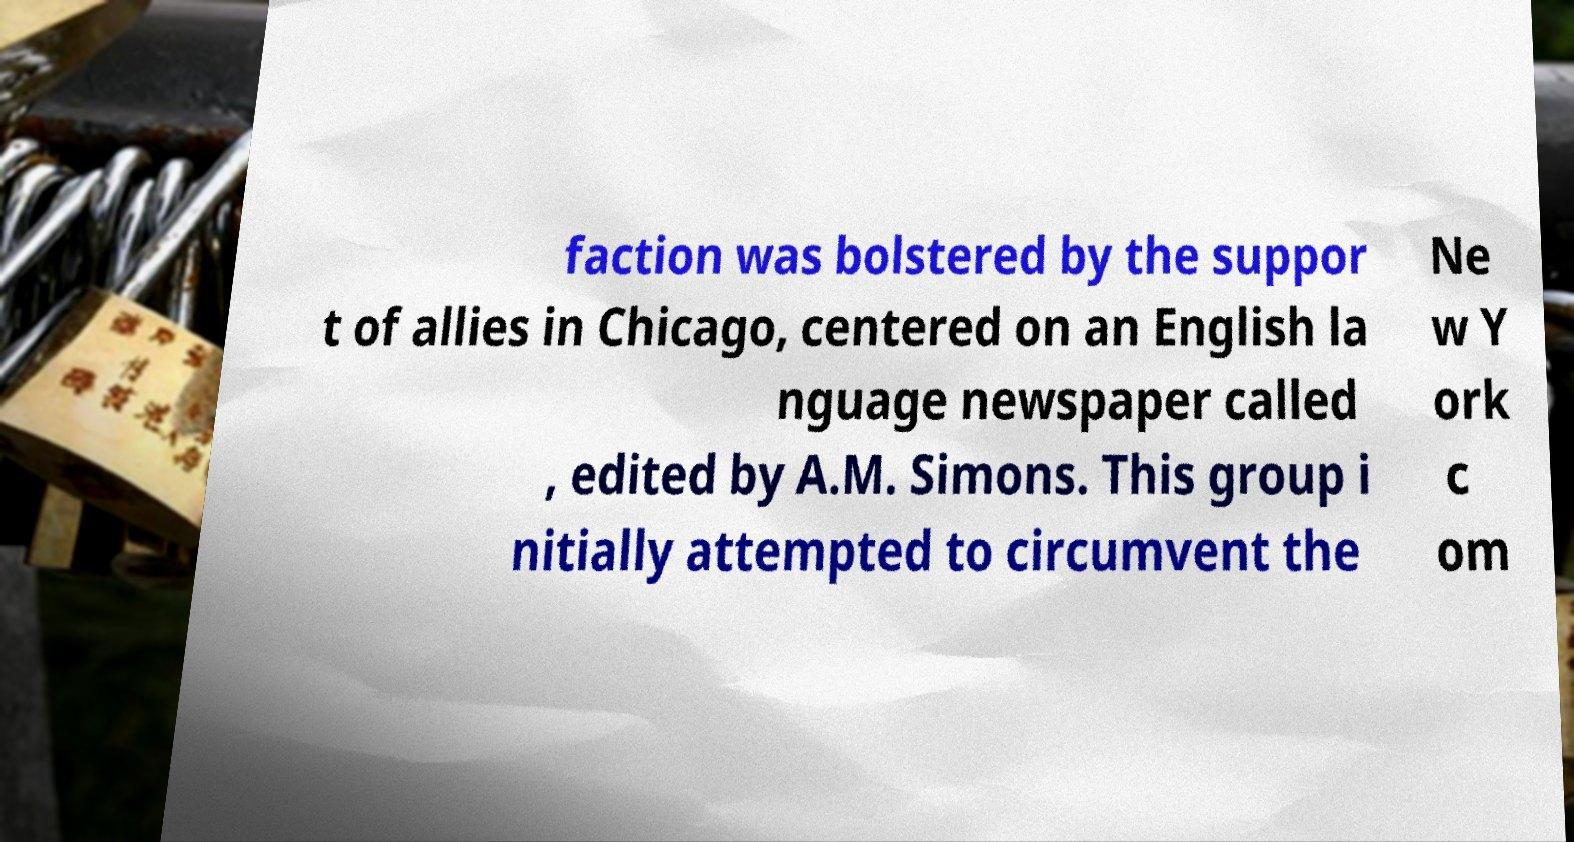What messages or text are displayed in this image? I need them in a readable, typed format. faction was bolstered by the suppor t of allies in Chicago, centered on an English la nguage newspaper called , edited by A.M. Simons. This group i nitially attempted to circumvent the Ne w Y ork c om 